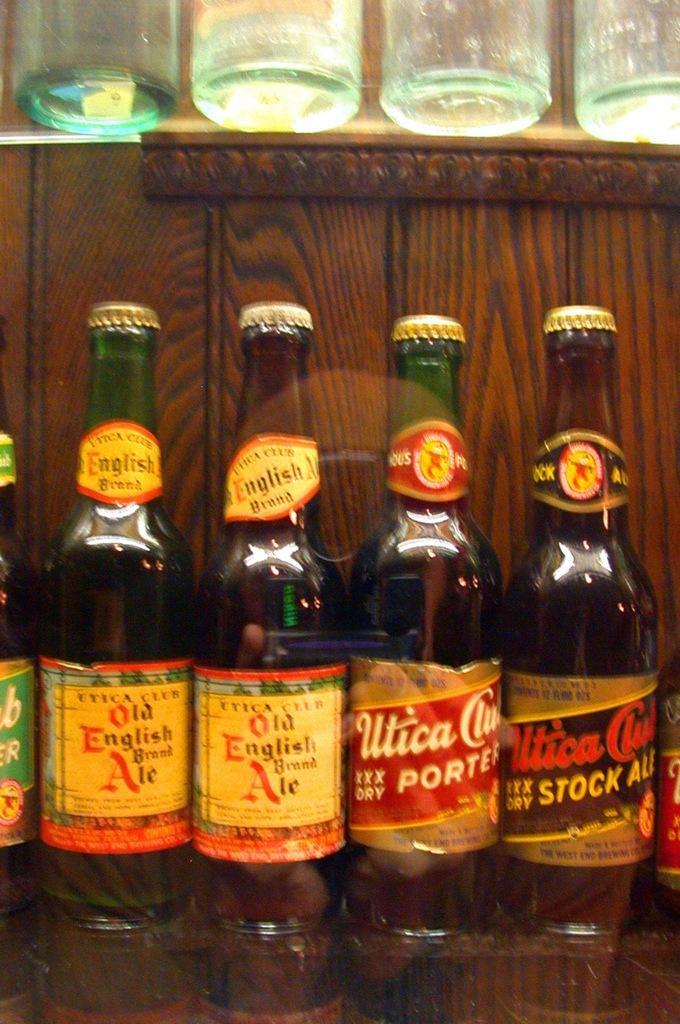Describe this image in one or two sentences. In this image we can see a wine bottles are kept on this wooden table. 